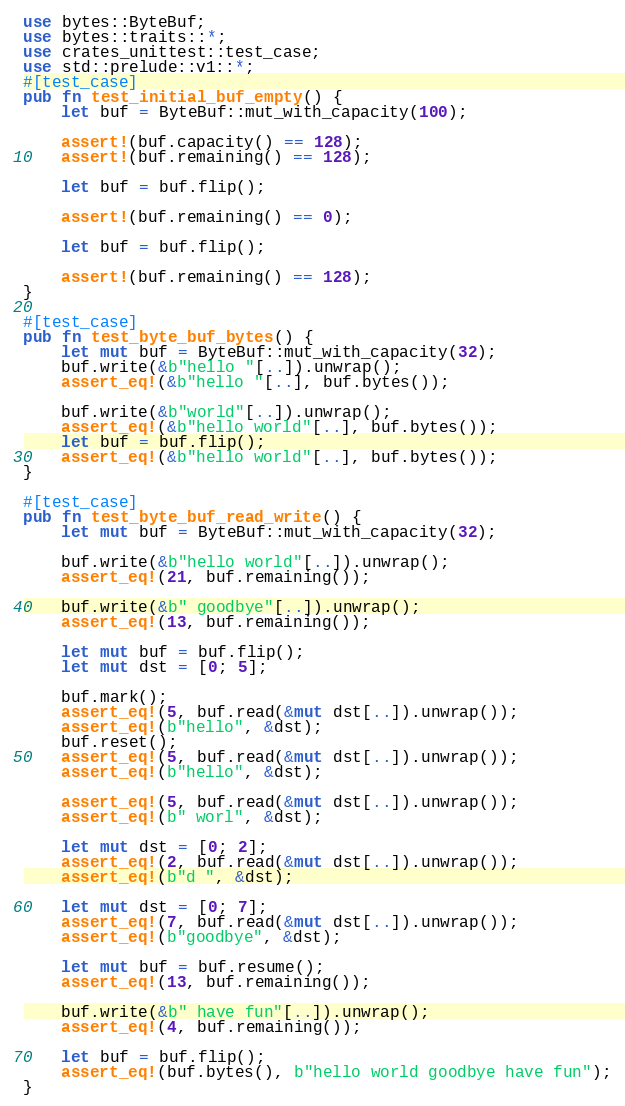<code> <loc_0><loc_0><loc_500><loc_500><_Rust_>use bytes::ByteBuf;
use bytes::traits::*;
use crates_unittest::test_case;
use std::prelude::v1::*;
#[test_case]
pub fn test_initial_buf_empty() {
    let buf = ByteBuf::mut_with_capacity(100);

    assert!(buf.capacity() == 128);
    assert!(buf.remaining() == 128);

    let buf = buf.flip();

    assert!(buf.remaining() == 0);

    let buf = buf.flip();

    assert!(buf.remaining() == 128);
}

#[test_case]
pub fn test_byte_buf_bytes() {
    let mut buf = ByteBuf::mut_with_capacity(32);
    buf.write(&b"hello "[..]).unwrap();
    assert_eq!(&b"hello "[..], buf.bytes());

    buf.write(&b"world"[..]).unwrap();
    assert_eq!(&b"hello world"[..], buf.bytes());
    let buf = buf.flip();
    assert_eq!(&b"hello world"[..], buf.bytes());
}

#[test_case]
pub fn test_byte_buf_read_write() {
    let mut buf = ByteBuf::mut_with_capacity(32);

    buf.write(&b"hello world"[..]).unwrap();
    assert_eq!(21, buf.remaining());

    buf.write(&b" goodbye"[..]).unwrap();
    assert_eq!(13, buf.remaining());

    let mut buf = buf.flip();
    let mut dst = [0; 5];

    buf.mark();
    assert_eq!(5, buf.read(&mut dst[..]).unwrap());
    assert_eq!(b"hello", &dst);
    buf.reset();
    assert_eq!(5, buf.read(&mut dst[..]).unwrap());
    assert_eq!(b"hello", &dst);

    assert_eq!(5, buf.read(&mut dst[..]).unwrap());
    assert_eq!(b" worl", &dst);

    let mut dst = [0; 2];
    assert_eq!(2, buf.read(&mut dst[..]).unwrap());
    assert_eq!(b"d ", &dst);

    let mut dst = [0; 7];
    assert_eq!(7, buf.read(&mut dst[..]).unwrap());
    assert_eq!(b"goodbye", &dst);

    let mut buf = buf.resume();
    assert_eq!(13, buf.remaining());

    buf.write(&b" have fun"[..]).unwrap();
    assert_eq!(4, buf.remaining());

    let buf = buf.flip();
    assert_eq!(buf.bytes(), b"hello world goodbye have fun");
}
</code> 